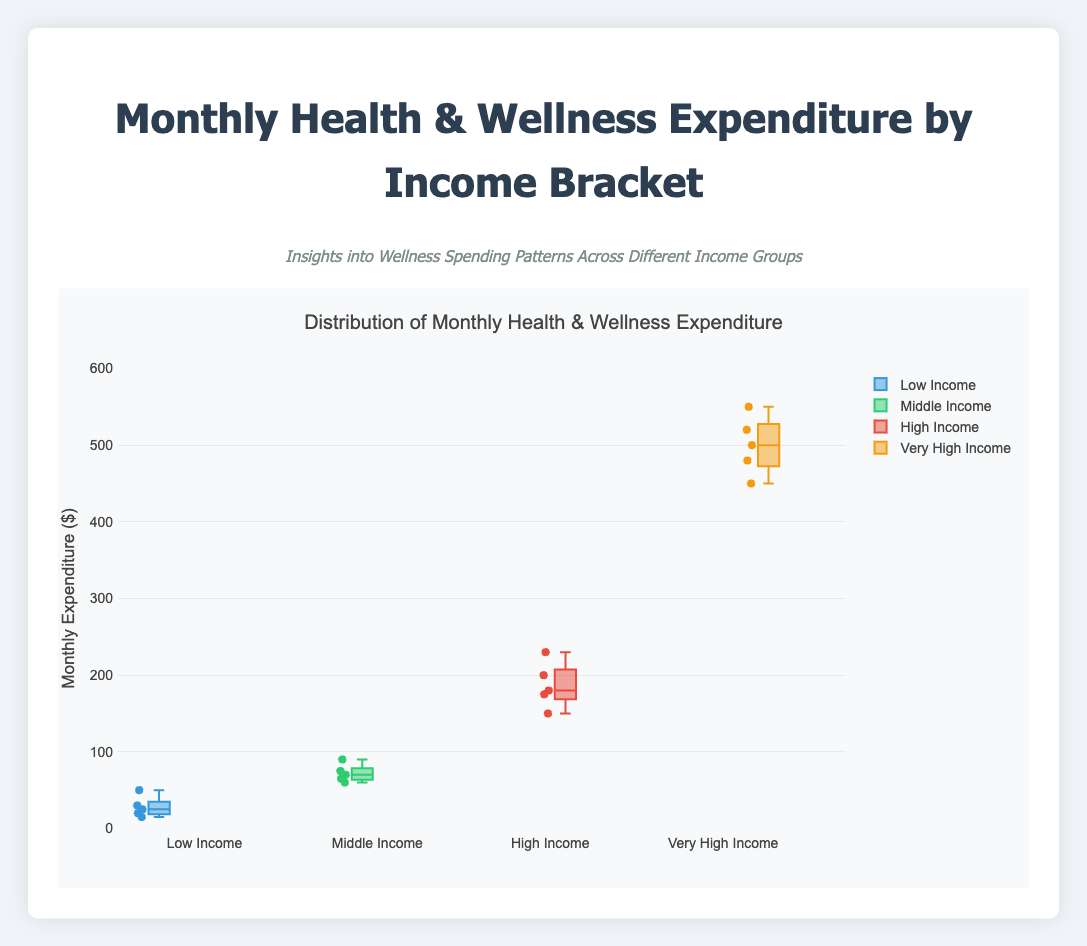What is the title of the plot? The title of the plot is displayed prominently at the top.
Answer: Monthly Health & Wellness Expenditure by Income Bracket Which income bracket shows the highest monthly expenditure median? The median value is represented by the line in the middle of the box in a box plot. Look for the highest median among the four income brackets.
Answer: Very High Income Which income bracket has the largest range of monthly expenditures? The range in a box plot is indicated by the distance between the minimum and maximum values within the box plot excluding outliers. Find the bracket with the widest range.
Answer: Very High Income Compare the median monthly expenditures between Low Income and Middle Income brackets. Which is higher and by how much? Compare the median lines within the Low Income and Middle Income boxes. Subtract the lower median from the higher one.
Answer: Middle Income is higher by approximately $45 What are the minimum and maximum expenditures in the High Income bracket? The minimum and maximum values are indicated by the ends of the "whiskers" in a box plot.
Answer: Minimum: $150, Maximum: $230 What's the interquartile range (IQR) for the Very High Income bracket? The IQR is the range between the first quartile (bottom of the box) and the third quartile (top of the box). Subtract the value at the first quartile from the value at the third quartile.
Answer: 500 - 450 = 50 How does the average monthly expenditure in the Low Income bracket compare to that in the High Income bracket? Calculate the average by summing the expenditures and dividing by the number of data points, then compare the two averages.
Answer: High Income's average is much higher What is the most significant outlier in the Middle Income bracket? Outliers are indicated by individual points outside the box-and-whisker ranges. Identify the most significant one.
Answer: $90 In which income bracket is the variability in expenditures the smallest, and what indicates this? Variability is indicated by the height of the box in a box plot. Look for the income bracket with the smallest box.
Answer: Middle Income How many data points are there in the Very High Income bracket, and what does this indicate about the group's spending pattern? Count the number of data points (individual dots) within and outside the box plot. Discuss what this indicates about spending patterns.
Answer: 5 data points, indicates consistent high spending 